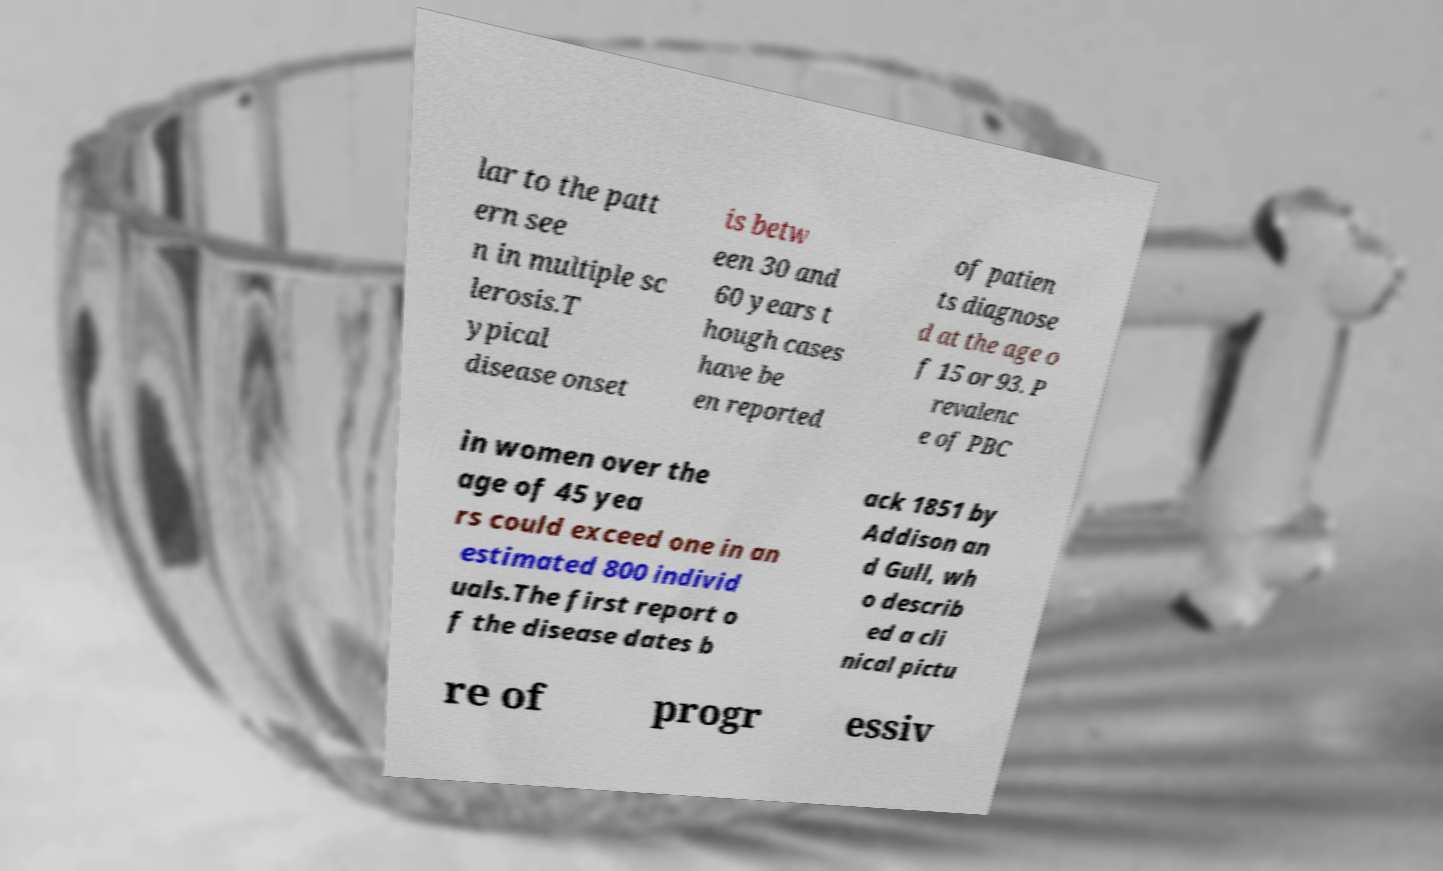Please read and relay the text visible in this image. What does it say? lar to the patt ern see n in multiple sc lerosis.T ypical disease onset is betw een 30 and 60 years t hough cases have be en reported of patien ts diagnose d at the age o f 15 or 93. P revalenc e of PBC in women over the age of 45 yea rs could exceed one in an estimated 800 individ uals.The first report o f the disease dates b ack 1851 by Addison an d Gull, wh o describ ed a cli nical pictu re of progr essiv 